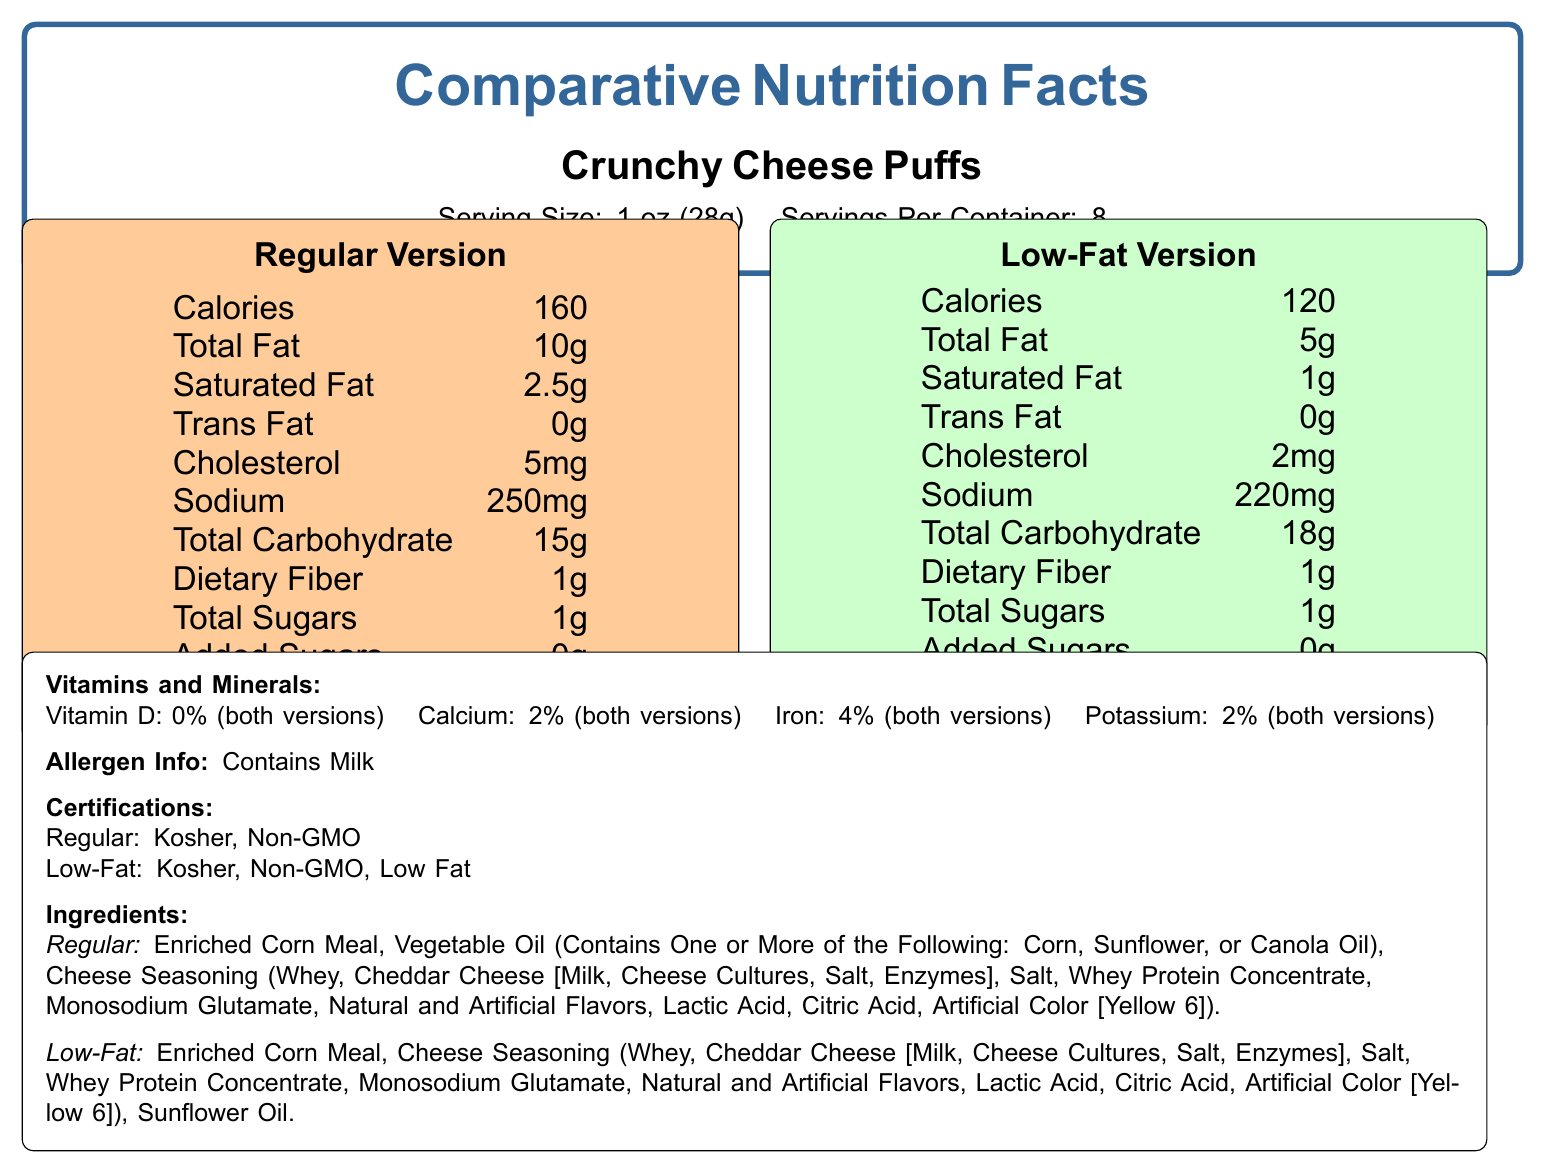what is the serving size for Crunchy Cheese Puffs? The serving size is stated under the product name at the top of the document.
Answer: 1 oz (28g) how many calories are in the regular version of Crunchy Cheese Puffs? The calorie content for the regular version is listed in the nutritional information table for the regular version.
Answer: 160 how much sodium does the low-fat version contain? The sodium content for the low-fat version is listed in the nutritional information table for the low-fat version.
Answer: 220mg are there any added sugars in either version? According to the nutritional information tables, both versions list 0g of added sugars.
Answer: No what certifications does the low-fat version have that the regular version does not? In the Certifications section, it mentions that the low-fat version has the "Low Fat" certification, which is not present for the regular version.
Answer: Low Fat how much total fat does the low-fat version have compared to the regular version? The total fat content is listed in the nutritional information tables for both versions.
Answer: The low-fat version has 5g of total fat, whereas the regular version has 10g of total fat. what ingredients differ between the regular and low-fat versions? The ingredients list shows that the regular version uses a combination of possible oils while the low-fat version specifies sunflower oil.
Answer: The low-fat version uses sunflower oil, while the regular version mentions "Vegetable Oil (Contains One or More of the Following: Corn, Sunflower, or Canola Oil)". which version has higher carbohydrate content? A. Regular Version B. Low-Fat Version The low-fat version has 18g of total carbohydrates, whereas the regular version has 15g.
Answer: B what is the cholesterol content of the low-fat version? A. 5mg B. 4mg C. 3mg D. 2mg The cholesterol content for the low-fat version is 2mg as listed in the nutritional information.
Answer: D how much iron do both versions contain? A. 0% B. 2% C. 4% D. 6% Both versions contain 4% iron as mentioned in the Vitamins and Minerals section.
Answer: C does the regular version contain more calories than the low-fat version? The regular version has 160 calories compared to the low-fat version's 120 calories.
Answer: Yes summarize the main differences between the regular and low-fat versions of Crunchy Cheese Puffs The regular and low-fat versions differ mainly in their nutritional values such as calories, fat, and sodium content. Ingredients vary slightly due to the type of oil used, and there are additional certifications for the low-fat version.
Answer: The main differences are that the low-fat version has fewer calories (120 vs. 160), lower total fat (5g vs. 10g), lower saturated fat (1g vs. 2.5g), lower cholesterol (2mg vs. 5mg), and lower sodium (220mg vs. 250mg). The low-fat version uses sunflower oil, while the regular version can use a combination of oils. Additionally, the low-fat version has a "Low Fat" certification not present in the regular version. describe the allergen information for Crunchy Cheese Puffs The allergen information states that both versions contain milk.
Answer: Contains: Milk is there any vitamin D in the Crunchy Cheese Puffs? The Vitamins and Minerals section indicates 0% vitamin D for both versions.
Answer: No why does the low-fat version have a lower fat content? The document provides the nutritional facts and ingredient lists but does not explain the specific manufacturing processes that cause the low-fat version to have lower fat content.
Answer: Cannot be determined 